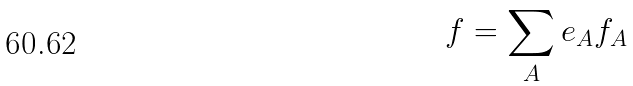Convert formula to latex. <formula><loc_0><loc_0><loc_500><loc_500>\ f = \sum _ { A } e _ { A } f _ { A }</formula> 